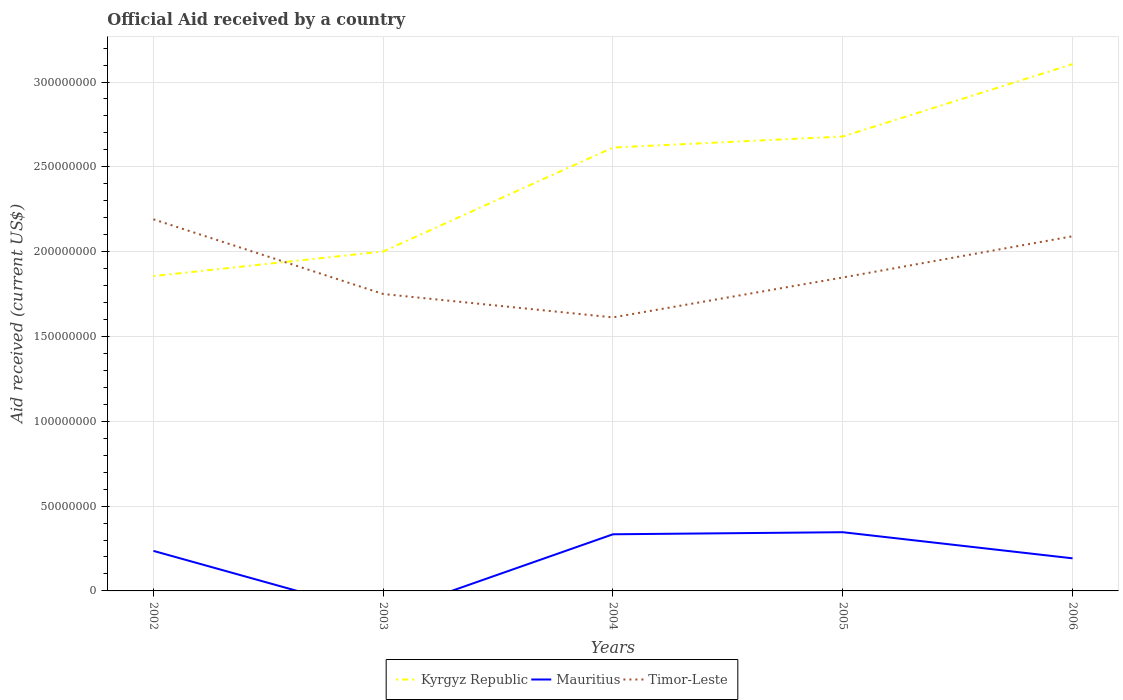How many different coloured lines are there?
Provide a short and direct response. 3. Does the line corresponding to Timor-Leste intersect with the line corresponding to Mauritius?
Give a very brief answer. No. Is the number of lines equal to the number of legend labels?
Provide a succinct answer. No. Across all years, what is the maximum net official aid received in Timor-Leste?
Ensure brevity in your answer.  1.61e+08. What is the total net official aid received in Timor-Leste in the graph?
Make the answer very short. 5.78e+07. What is the difference between the highest and the second highest net official aid received in Mauritius?
Give a very brief answer. 3.46e+07. What is the difference between the highest and the lowest net official aid received in Kyrgyz Republic?
Give a very brief answer. 3. Does the graph contain any zero values?
Offer a terse response. Yes. Does the graph contain grids?
Offer a very short reply. Yes. What is the title of the graph?
Make the answer very short. Official Aid received by a country. What is the label or title of the Y-axis?
Your answer should be compact. Aid received (current US$). What is the Aid received (current US$) in Kyrgyz Republic in 2002?
Your answer should be compact. 1.86e+08. What is the Aid received (current US$) in Mauritius in 2002?
Provide a short and direct response. 2.36e+07. What is the Aid received (current US$) in Timor-Leste in 2002?
Ensure brevity in your answer.  2.19e+08. What is the Aid received (current US$) of Kyrgyz Republic in 2003?
Offer a terse response. 2.00e+08. What is the Aid received (current US$) in Timor-Leste in 2003?
Make the answer very short. 1.75e+08. What is the Aid received (current US$) of Kyrgyz Republic in 2004?
Offer a terse response. 2.61e+08. What is the Aid received (current US$) in Mauritius in 2004?
Ensure brevity in your answer.  3.34e+07. What is the Aid received (current US$) in Timor-Leste in 2004?
Provide a short and direct response. 1.61e+08. What is the Aid received (current US$) in Kyrgyz Republic in 2005?
Ensure brevity in your answer.  2.68e+08. What is the Aid received (current US$) in Mauritius in 2005?
Offer a terse response. 3.46e+07. What is the Aid received (current US$) in Timor-Leste in 2005?
Give a very brief answer. 1.85e+08. What is the Aid received (current US$) of Kyrgyz Republic in 2006?
Your answer should be very brief. 3.11e+08. What is the Aid received (current US$) in Mauritius in 2006?
Make the answer very short. 1.92e+07. What is the Aid received (current US$) in Timor-Leste in 2006?
Your answer should be very brief. 2.09e+08. Across all years, what is the maximum Aid received (current US$) in Kyrgyz Republic?
Your answer should be very brief. 3.11e+08. Across all years, what is the maximum Aid received (current US$) in Mauritius?
Provide a succinct answer. 3.46e+07. Across all years, what is the maximum Aid received (current US$) in Timor-Leste?
Give a very brief answer. 2.19e+08. Across all years, what is the minimum Aid received (current US$) in Kyrgyz Republic?
Provide a short and direct response. 1.86e+08. Across all years, what is the minimum Aid received (current US$) of Timor-Leste?
Offer a very short reply. 1.61e+08. What is the total Aid received (current US$) in Kyrgyz Republic in the graph?
Give a very brief answer. 1.23e+09. What is the total Aid received (current US$) in Mauritius in the graph?
Provide a short and direct response. 1.11e+08. What is the total Aid received (current US$) of Timor-Leste in the graph?
Provide a succinct answer. 9.49e+08. What is the difference between the Aid received (current US$) of Kyrgyz Republic in 2002 and that in 2003?
Make the answer very short. -1.45e+07. What is the difference between the Aid received (current US$) in Timor-Leste in 2002 and that in 2003?
Make the answer very short. 4.40e+07. What is the difference between the Aid received (current US$) in Kyrgyz Republic in 2002 and that in 2004?
Offer a terse response. -7.58e+07. What is the difference between the Aid received (current US$) of Mauritius in 2002 and that in 2004?
Your response must be concise. -9.79e+06. What is the difference between the Aid received (current US$) of Timor-Leste in 2002 and that in 2004?
Provide a succinct answer. 5.78e+07. What is the difference between the Aid received (current US$) in Kyrgyz Republic in 2002 and that in 2005?
Make the answer very short. -8.23e+07. What is the difference between the Aid received (current US$) in Mauritius in 2002 and that in 2005?
Offer a very short reply. -1.10e+07. What is the difference between the Aid received (current US$) in Timor-Leste in 2002 and that in 2005?
Keep it short and to the point. 3.43e+07. What is the difference between the Aid received (current US$) of Kyrgyz Republic in 2002 and that in 2006?
Provide a short and direct response. -1.25e+08. What is the difference between the Aid received (current US$) in Mauritius in 2002 and that in 2006?
Offer a terse response. 4.38e+06. What is the difference between the Aid received (current US$) of Timor-Leste in 2002 and that in 2006?
Keep it short and to the point. 9.98e+06. What is the difference between the Aid received (current US$) in Kyrgyz Republic in 2003 and that in 2004?
Provide a short and direct response. -6.13e+07. What is the difference between the Aid received (current US$) of Timor-Leste in 2003 and that in 2004?
Offer a terse response. 1.38e+07. What is the difference between the Aid received (current US$) of Kyrgyz Republic in 2003 and that in 2005?
Give a very brief answer. -6.78e+07. What is the difference between the Aid received (current US$) in Timor-Leste in 2003 and that in 2005?
Keep it short and to the point. -9.73e+06. What is the difference between the Aid received (current US$) of Kyrgyz Republic in 2003 and that in 2006?
Your response must be concise. -1.10e+08. What is the difference between the Aid received (current US$) in Timor-Leste in 2003 and that in 2006?
Provide a short and direct response. -3.40e+07. What is the difference between the Aid received (current US$) in Kyrgyz Republic in 2004 and that in 2005?
Your answer should be compact. -6.51e+06. What is the difference between the Aid received (current US$) of Mauritius in 2004 and that in 2005?
Offer a terse response. -1.22e+06. What is the difference between the Aid received (current US$) of Timor-Leste in 2004 and that in 2005?
Ensure brevity in your answer.  -2.35e+07. What is the difference between the Aid received (current US$) of Kyrgyz Republic in 2004 and that in 2006?
Keep it short and to the point. -4.92e+07. What is the difference between the Aid received (current US$) of Mauritius in 2004 and that in 2006?
Make the answer very short. 1.42e+07. What is the difference between the Aid received (current US$) in Timor-Leste in 2004 and that in 2006?
Offer a terse response. -4.78e+07. What is the difference between the Aid received (current US$) of Kyrgyz Republic in 2005 and that in 2006?
Provide a succinct answer. -4.27e+07. What is the difference between the Aid received (current US$) of Mauritius in 2005 and that in 2006?
Offer a terse response. 1.54e+07. What is the difference between the Aid received (current US$) of Timor-Leste in 2005 and that in 2006?
Offer a very short reply. -2.43e+07. What is the difference between the Aid received (current US$) in Kyrgyz Republic in 2002 and the Aid received (current US$) in Timor-Leste in 2003?
Keep it short and to the point. 1.06e+07. What is the difference between the Aid received (current US$) of Mauritius in 2002 and the Aid received (current US$) of Timor-Leste in 2003?
Provide a short and direct response. -1.51e+08. What is the difference between the Aid received (current US$) of Kyrgyz Republic in 2002 and the Aid received (current US$) of Mauritius in 2004?
Your answer should be very brief. 1.52e+08. What is the difference between the Aid received (current US$) of Kyrgyz Republic in 2002 and the Aid received (current US$) of Timor-Leste in 2004?
Provide a short and direct response. 2.44e+07. What is the difference between the Aid received (current US$) in Mauritius in 2002 and the Aid received (current US$) in Timor-Leste in 2004?
Your answer should be very brief. -1.38e+08. What is the difference between the Aid received (current US$) of Kyrgyz Republic in 2002 and the Aid received (current US$) of Mauritius in 2005?
Your response must be concise. 1.51e+08. What is the difference between the Aid received (current US$) in Kyrgyz Republic in 2002 and the Aid received (current US$) in Timor-Leste in 2005?
Your answer should be very brief. 8.50e+05. What is the difference between the Aid received (current US$) in Mauritius in 2002 and the Aid received (current US$) in Timor-Leste in 2005?
Offer a very short reply. -1.61e+08. What is the difference between the Aid received (current US$) of Kyrgyz Republic in 2002 and the Aid received (current US$) of Mauritius in 2006?
Your response must be concise. 1.66e+08. What is the difference between the Aid received (current US$) in Kyrgyz Republic in 2002 and the Aid received (current US$) in Timor-Leste in 2006?
Keep it short and to the point. -2.35e+07. What is the difference between the Aid received (current US$) in Mauritius in 2002 and the Aid received (current US$) in Timor-Leste in 2006?
Ensure brevity in your answer.  -1.85e+08. What is the difference between the Aid received (current US$) in Kyrgyz Republic in 2003 and the Aid received (current US$) in Mauritius in 2004?
Provide a succinct answer. 1.67e+08. What is the difference between the Aid received (current US$) in Kyrgyz Republic in 2003 and the Aid received (current US$) in Timor-Leste in 2004?
Your answer should be very brief. 3.89e+07. What is the difference between the Aid received (current US$) of Kyrgyz Republic in 2003 and the Aid received (current US$) of Mauritius in 2005?
Offer a very short reply. 1.65e+08. What is the difference between the Aid received (current US$) in Kyrgyz Republic in 2003 and the Aid received (current US$) in Timor-Leste in 2005?
Your response must be concise. 1.53e+07. What is the difference between the Aid received (current US$) in Kyrgyz Republic in 2003 and the Aid received (current US$) in Mauritius in 2006?
Your answer should be very brief. 1.81e+08. What is the difference between the Aid received (current US$) in Kyrgyz Republic in 2003 and the Aid received (current US$) in Timor-Leste in 2006?
Provide a succinct answer. -8.97e+06. What is the difference between the Aid received (current US$) of Kyrgyz Republic in 2004 and the Aid received (current US$) of Mauritius in 2005?
Offer a very short reply. 2.27e+08. What is the difference between the Aid received (current US$) in Kyrgyz Republic in 2004 and the Aid received (current US$) in Timor-Leste in 2005?
Offer a very short reply. 7.66e+07. What is the difference between the Aid received (current US$) of Mauritius in 2004 and the Aid received (current US$) of Timor-Leste in 2005?
Your response must be concise. -1.51e+08. What is the difference between the Aid received (current US$) in Kyrgyz Republic in 2004 and the Aid received (current US$) in Mauritius in 2006?
Give a very brief answer. 2.42e+08. What is the difference between the Aid received (current US$) of Kyrgyz Republic in 2004 and the Aid received (current US$) of Timor-Leste in 2006?
Your answer should be compact. 5.23e+07. What is the difference between the Aid received (current US$) of Mauritius in 2004 and the Aid received (current US$) of Timor-Leste in 2006?
Keep it short and to the point. -1.76e+08. What is the difference between the Aid received (current US$) in Kyrgyz Republic in 2005 and the Aid received (current US$) in Mauritius in 2006?
Your response must be concise. 2.49e+08. What is the difference between the Aid received (current US$) in Kyrgyz Republic in 2005 and the Aid received (current US$) in Timor-Leste in 2006?
Provide a succinct answer. 5.88e+07. What is the difference between the Aid received (current US$) in Mauritius in 2005 and the Aid received (current US$) in Timor-Leste in 2006?
Give a very brief answer. -1.74e+08. What is the average Aid received (current US$) in Kyrgyz Republic per year?
Offer a terse response. 2.45e+08. What is the average Aid received (current US$) in Mauritius per year?
Ensure brevity in your answer.  2.22e+07. What is the average Aid received (current US$) of Timor-Leste per year?
Ensure brevity in your answer.  1.90e+08. In the year 2002, what is the difference between the Aid received (current US$) of Kyrgyz Republic and Aid received (current US$) of Mauritius?
Offer a very short reply. 1.62e+08. In the year 2002, what is the difference between the Aid received (current US$) of Kyrgyz Republic and Aid received (current US$) of Timor-Leste?
Your answer should be compact. -3.34e+07. In the year 2002, what is the difference between the Aid received (current US$) in Mauritius and Aid received (current US$) in Timor-Leste?
Ensure brevity in your answer.  -1.95e+08. In the year 2003, what is the difference between the Aid received (current US$) in Kyrgyz Republic and Aid received (current US$) in Timor-Leste?
Make the answer very short. 2.51e+07. In the year 2004, what is the difference between the Aid received (current US$) in Kyrgyz Republic and Aid received (current US$) in Mauritius?
Ensure brevity in your answer.  2.28e+08. In the year 2004, what is the difference between the Aid received (current US$) of Kyrgyz Republic and Aid received (current US$) of Timor-Leste?
Make the answer very short. 1.00e+08. In the year 2004, what is the difference between the Aid received (current US$) in Mauritius and Aid received (current US$) in Timor-Leste?
Your answer should be compact. -1.28e+08. In the year 2005, what is the difference between the Aid received (current US$) of Kyrgyz Republic and Aid received (current US$) of Mauritius?
Ensure brevity in your answer.  2.33e+08. In the year 2005, what is the difference between the Aid received (current US$) of Kyrgyz Republic and Aid received (current US$) of Timor-Leste?
Ensure brevity in your answer.  8.31e+07. In the year 2005, what is the difference between the Aid received (current US$) of Mauritius and Aid received (current US$) of Timor-Leste?
Offer a very short reply. -1.50e+08. In the year 2006, what is the difference between the Aid received (current US$) in Kyrgyz Republic and Aid received (current US$) in Mauritius?
Your response must be concise. 2.91e+08. In the year 2006, what is the difference between the Aid received (current US$) in Kyrgyz Republic and Aid received (current US$) in Timor-Leste?
Keep it short and to the point. 1.01e+08. In the year 2006, what is the difference between the Aid received (current US$) of Mauritius and Aid received (current US$) of Timor-Leste?
Provide a succinct answer. -1.90e+08. What is the ratio of the Aid received (current US$) in Kyrgyz Republic in 2002 to that in 2003?
Ensure brevity in your answer.  0.93. What is the ratio of the Aid received (current US$) of Timor-Leste in 2002 to that in 2003?
Offer a terse response. 1.25. What is the ratio of the Aid received (current US$) in Kyrgyz Republic in 2002 to that in 2004?
Offer a terse response. 0.71. What is the ratio of the Aid received (current US$) of Mauritius in 2002 to that in 2004?
Your answer should be very brief. 0.71. What is the ratio of the Aid received (current US$) in Timor-Leste in 2002 to that in 2004?
Your answer should be compact. 1.36. What is the ratio of the Aid received (current US$) of Kyrgyz Republic in 2002 to that in 2005?
Provide a succinct answer. 0.69. What is the ratio of the Aid received (current US$) in Mauritius in 2002 to that in 2005?
Provide a succinct answer. 0.68. What is the ratio of the Aid received (current US$) in Timor-Leste in 2002 to that in 2005?
Provide a succinct answer. 1.19. What is the ratio of the Aid received (current US$) of Kyrgyz Republic in 2002 to that in 2006?
Offer a terse response. 0.6. What is the ratio of the Aid received (current US$) of Mauritius in 2002 to that in 2006?
Your answer should be very brief. 1.23. What is the ratio of the Aid received (current US$) in Timor-Leste in 2002 to that in 2006?
Keep it short and to the point. 1.05. What is the ratio of the Aid received (current US$) of Kyrgyz Republic in 2003 to that in 2004?
Keep it short and to the point. 0.77. What is the ratio of the Aid received (current US$) in Timor-Leste in 2003 to that in 2004?
Provide a short and direct response. 1.09. What is the ratio of the Aid received (current US$) of Kyrgyz Republic in 2003 to that in 2005?
Provide a short and direct response. 0.75. What is the ratio of the Aid received (current US$) in Timor-Leste in 2003 to that in 2005?
Offer a very short reply. 0.95. What is the ratio of the Aid received (current US$) in Kyrgyz Republic in 2003 to that in 2006?
Your answer should be very brief. 0.64. What is the ratio of the Aid received (current US$) of Timor-Leste in 2003 to that in 2006?
Your answer should be compact. 0.84. What is the ratio of the Aid received (current US$) of Kyrgyz Republic in 2004 to that in 2005?
Give a very brief answer. 0.98. What is the ratio of the Aid received (current US$) in Mauritius in 2004 to that in 2005?
Your response must be concise. 0.96. What is the ratio of the Aid received (current US$) in Timor-Leste in 2004 to that in 2005?
Your answer should be very brief. 0.87. What is the ratio of the Aid received (current US$) in Kyrgyz Republic in 2004 to that in 2006?
Your response must be concise. 0.84. What is the ratio of the Aid received (current US$) of Mauritius in 2004 to that in 2006?
Provide a short and direct response. 1.74. What is the ratio of the Aid received (current US$) of Timor-Leste in 2004 to that in 2006?
Your answer should be compact. 0.77. What is the ratio of the Aid received (current US$) of Kyrgyz Republic in 2005 to that in 2006?
Keep it short and to the point. 0.86. What is the ratio of the Aid received (current US$) of Mauritius in 2005 to that in 2006?
Your answer should be very brief. 1.8. What is the ratio of the Aid received (current US$) in Timor-Leste in 2005 to that in 2006?
Keep it short and to the point. 0.88. What is the difference between the highest and the second highest Aid received (current US$) in Kyrgyz Republic?
Provide a short and direct response. 4.27e+07. What is the difference between the highest and the second highest Aid received (current US$) of Mauritius?
Offer a very short reply. 1.22e+06. What is the difference between the highest and the second highest Aid received (current US$) of Timor-Leste?
Make the answer very short. 9.98e+06. What is the difference between the highest and the lowest Aid received (current US$) of Kyrgyz Republic?
Your answer should be compact. 1.25e+08. What is the difference between the highest and the lowest Aid received (current US$) in Mauritius?
Provide a short and direct response. 3.46e+07. What is the difference between the highest and the lowest Aid received (current US$) of Timor-Leste?
Keep it short and to the point. 5.78e+07. 